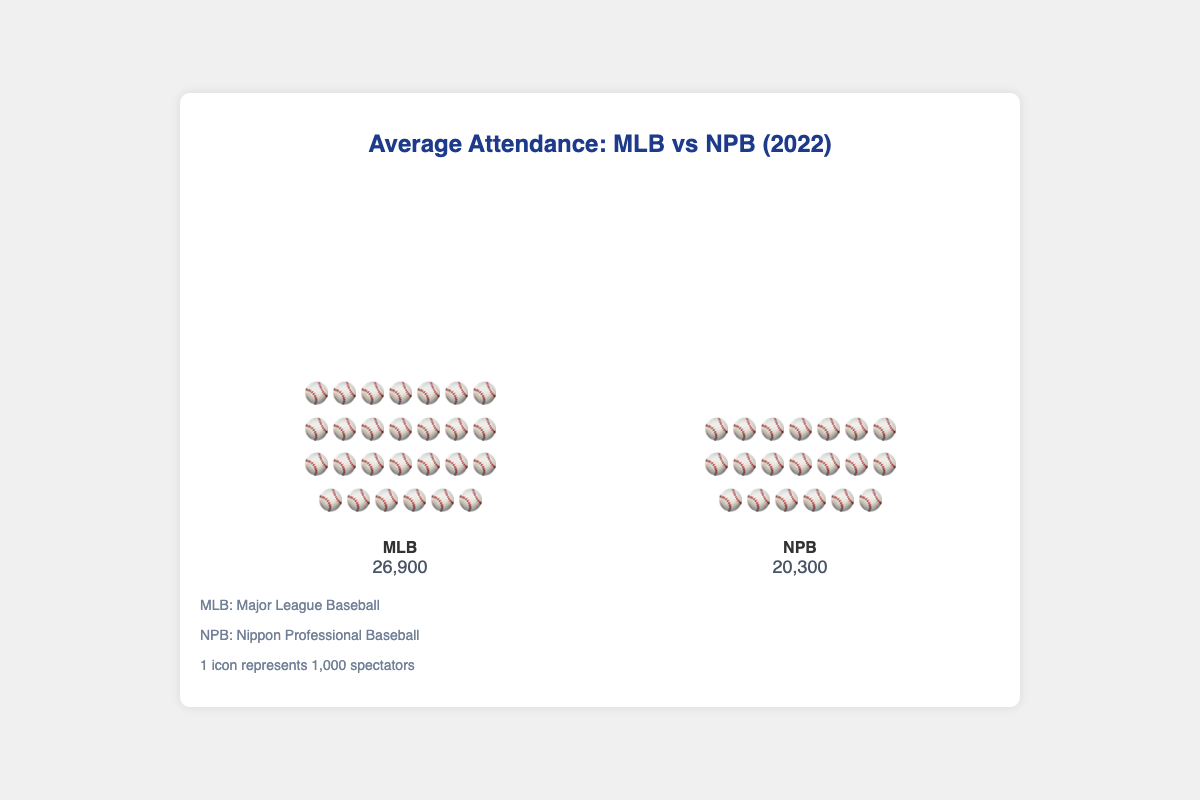What is the title of the plot? The title is located at the top of the figure, providing an overview of what the plot is about. By reading it, we understand the comparison between MLB and NPB in terms of average attendance for the year 2022.
Answer: Average Attendance: MLB vs NPB (2022) How many icons represent MLB's average attendance? Each icon represents 1,000 spectators, as stated in the notes section. The MLB section contains a total of 27 icons.
Answer: 27 How does the average attendance of MLB compare to NPB? By comparing the number of icons in each section, MLB has 27 icons while NPB has 20 icons, showing that MLB has a greater average attendance.
Answer: MLB has a greater average attendance What is the average attendance for NPB? The numerical value is listed under the NPB section, indicating the average attendance in thousands.
Answer: 20,300 By how much is MLB's average attendance higher than NPB's? First, find the value for MLB (26,900) and NPB (20,300) from the plot. Subtract NPB’s value from MLB’s value to determine the difference. 26,900 - 20,300 = 6,600.
Answer: 6,600 What does one icon represent in the plot? According to the notes provided at the bottom of the figure, each icon represents 1,000 spectators.
Answer: 1,000 spectators Which league has fewer average spectators per game in 2022? By comparing the numerical values given for both leagues, NPB has a lower average attendance (20,300) compared to MLB (26,900).
Answer: NPB What do the icons used in the plot represent? The icons are visually depicting the number of spectators, with each icon representing 1,000 spectators as stated in the notes section.
Answer: Baseball players representing 1,000 spectators each If the NPB increased its average attendance by 5,000, how would it compare to MLB's attendance? Adding 5,000 to NPB’s current average attendance: 20,300 + 5,000 = 25,300. This is still less than MLB's average attendance of 26,900.
Answer: NPB would have 1,600 fewer spectators than MLB What are the categories compared in this plot? The categories are indicated by the labels under each bar, showing that the plot compares MLB (Major League Baseball) and NPB (Nippon Professional Baseball).
Answer: MLB and NPB 